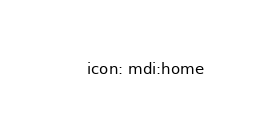Convert code to text. <code><loc_0><loc_0><loc_500><loc_500><_YAML_>    icon: mdi:home</code> 